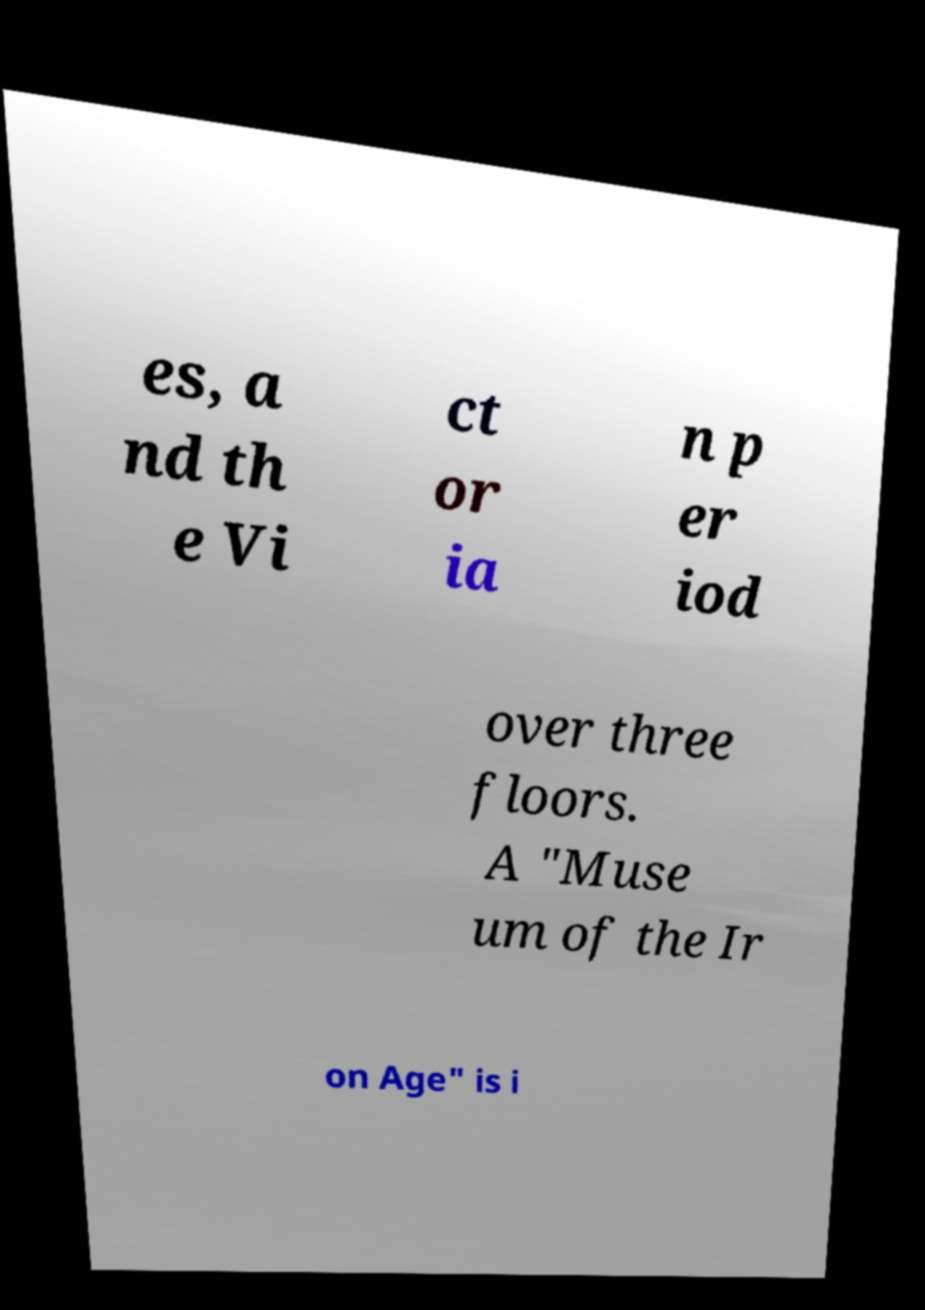There's text embedded in this image that I need extracted. Can you transcribe it verbatim? es, a nd th e Vi ct or ia n p er iod over three floors. A "Muse um of the Ir on Age" is i 